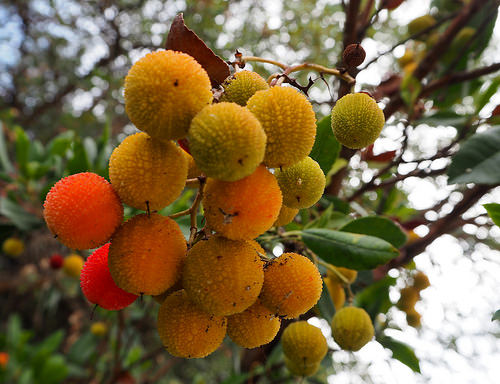<image>
Is the stem behind the leaf? No. The stem is not behind the leaf. From this viewpoint, the stem appears to be positioned elsewhere in the scene. 